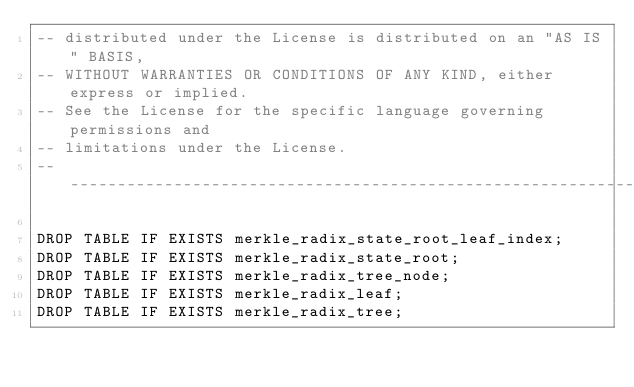Convert code to text. <code><loc_0><loc_0><loc_500><loc_500><_SQL_>-- distributed under the License is distributed on an "AS IS" BASIS,
-- WITHOUT WARRANTIES OR CONDITIONS OF ANY KIND, either express or implied.
-- See the License for the specific language governing permissions and
-- limitations under the License.
-- -----------------------------------------------------------------------------

DROP TABLE IF EXISTS merkle_radix_state_root_leaf_index;
DROP TABLE IF EXISTS merkle_radix_state_root;
DROP TABLE IF EXISTS merkle_radix_tree_node;
DROP TABLE IF EXISTS merkle_radix_leaf;
DROP TABLE IF EXISTS merkle_radix_tree;
</code> 